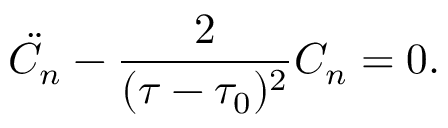<formula> <loc_0><loc_0><loc_500><loc_500>\ddot { C } _ { n } - \frac { 2 } { ( \tau - \tau _ { 0 } ) ^ { 2 } } C _ { n } = 0 .</formula> 